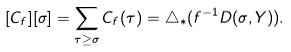<formula> <loc_0><loc_0><loc_500><loc_500>[ C _ { f } ] [ \sigma ] = \sum _ { \tau \geq \sigma } C _ { f } ( \tau ) = \triangle _ { \ast } ( f ^ { - 1 } D ( \sigma , Y ) ) .</formula> 